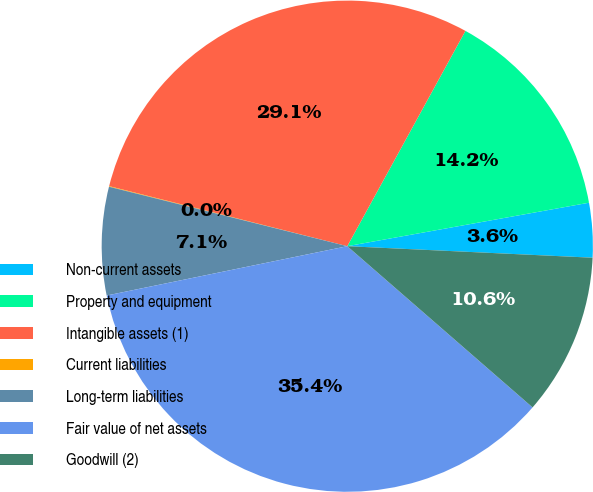Convert chart. <chart><loc_0><loc_0><loc_500><loc_500><pie_chart><fcel>Non-current assets<fcel>Property and equipment<fcel>Intangible assets (1)<fcel>Current liabilities<fcel>Long-term liabilities<fcel>Fair value of net assets<fcel>Goodwill (2)<nl><fcel>3.58%<fcel>14.18%<fcel>29.06%<fcel>0.04%<fcel>7.11%<fcel>35.39%<fcel>10.65%<nl></chart> 